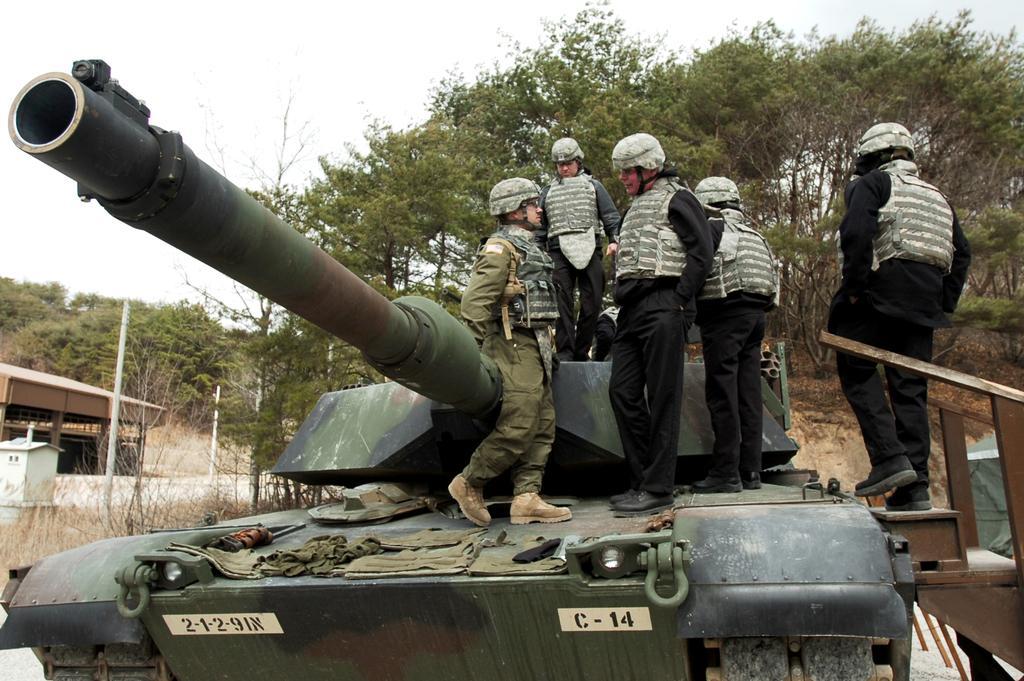Could you give a brief overview of what you see in this image? In this picture I can see a tank in front on which there are few people who are standing and on the right side of this image I see the steps on which there is a person. In the background I see number of trees, sky and I see few poles and on the left side of this image I see a building. 